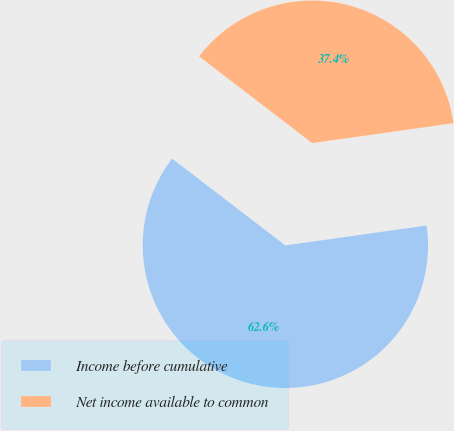Convert chart. <chart><loc_0><loc_0><loc_500><loc_500><pie_chart><fcel>Income before cumulative<fcel>Net income available to common<nl><fcel>62.64%<fcel>37.36%<nl></chart> 